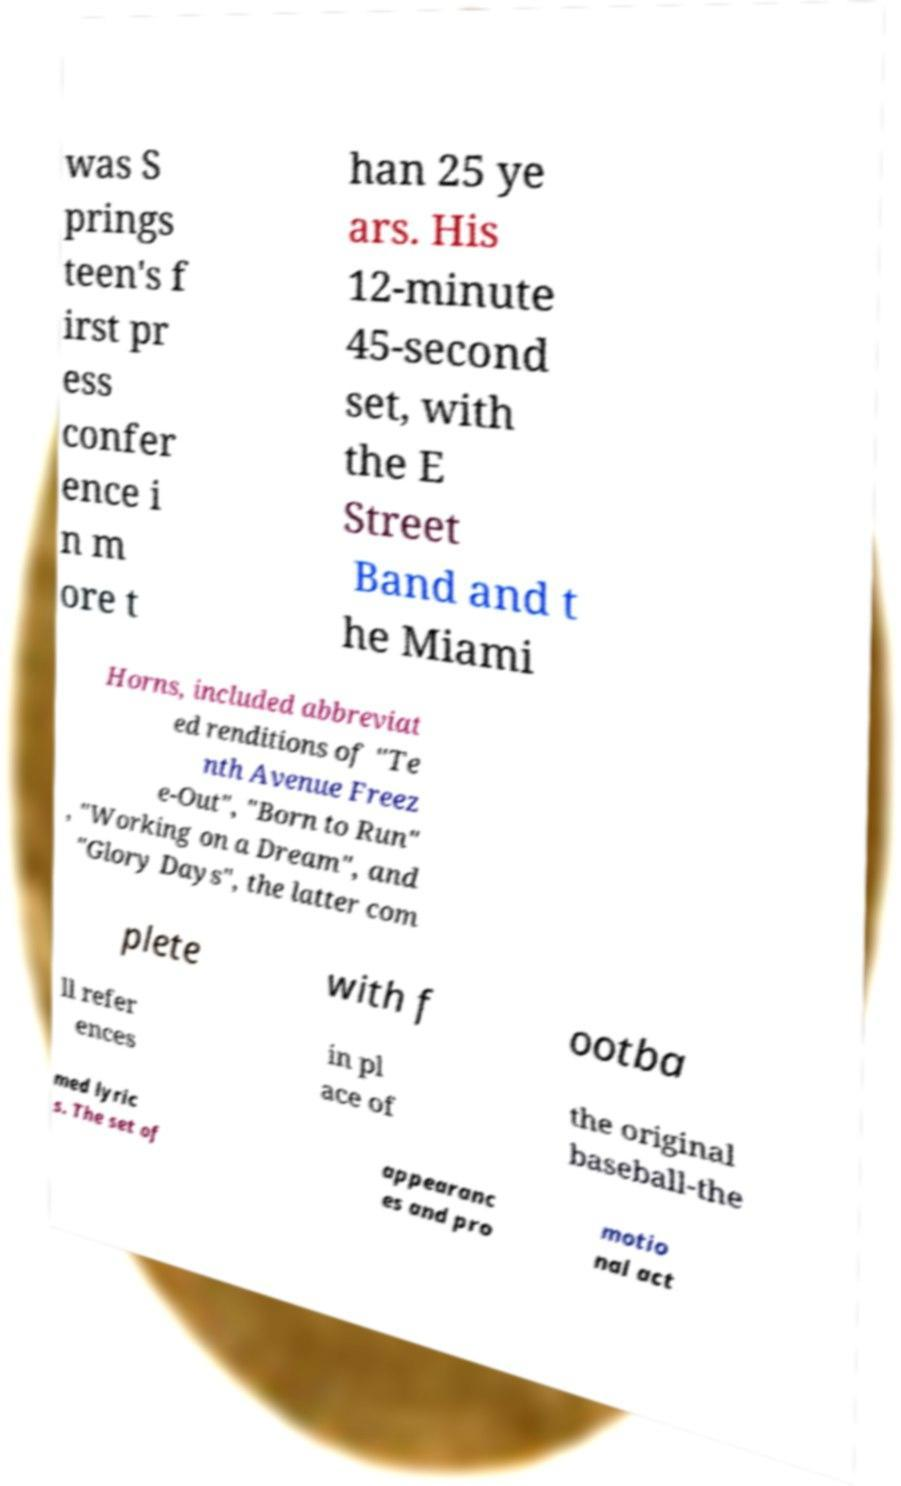For documentation purposes, I need the text within this image transcribed. Could you provide that? was S prings teen's f irst pr ess confer ence i n m ore t han 25 ye ars. His 12-minute 45-second set, with the E Street Band and t he Miami Horns, included abbreviat ed renditions of "Te nth Avenue Freez e-Out", "Born to Run" , "Working on a Dream", and "Glory Days", the latter com plete with f ootba ll refer ences in pl ace of the original baseball-the med lyric s. The set of appearanc es and pro motio nal act 